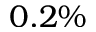<formula> <loc_0><loc_0><loc_500><loc_500>0 . 2 \%</formula> 